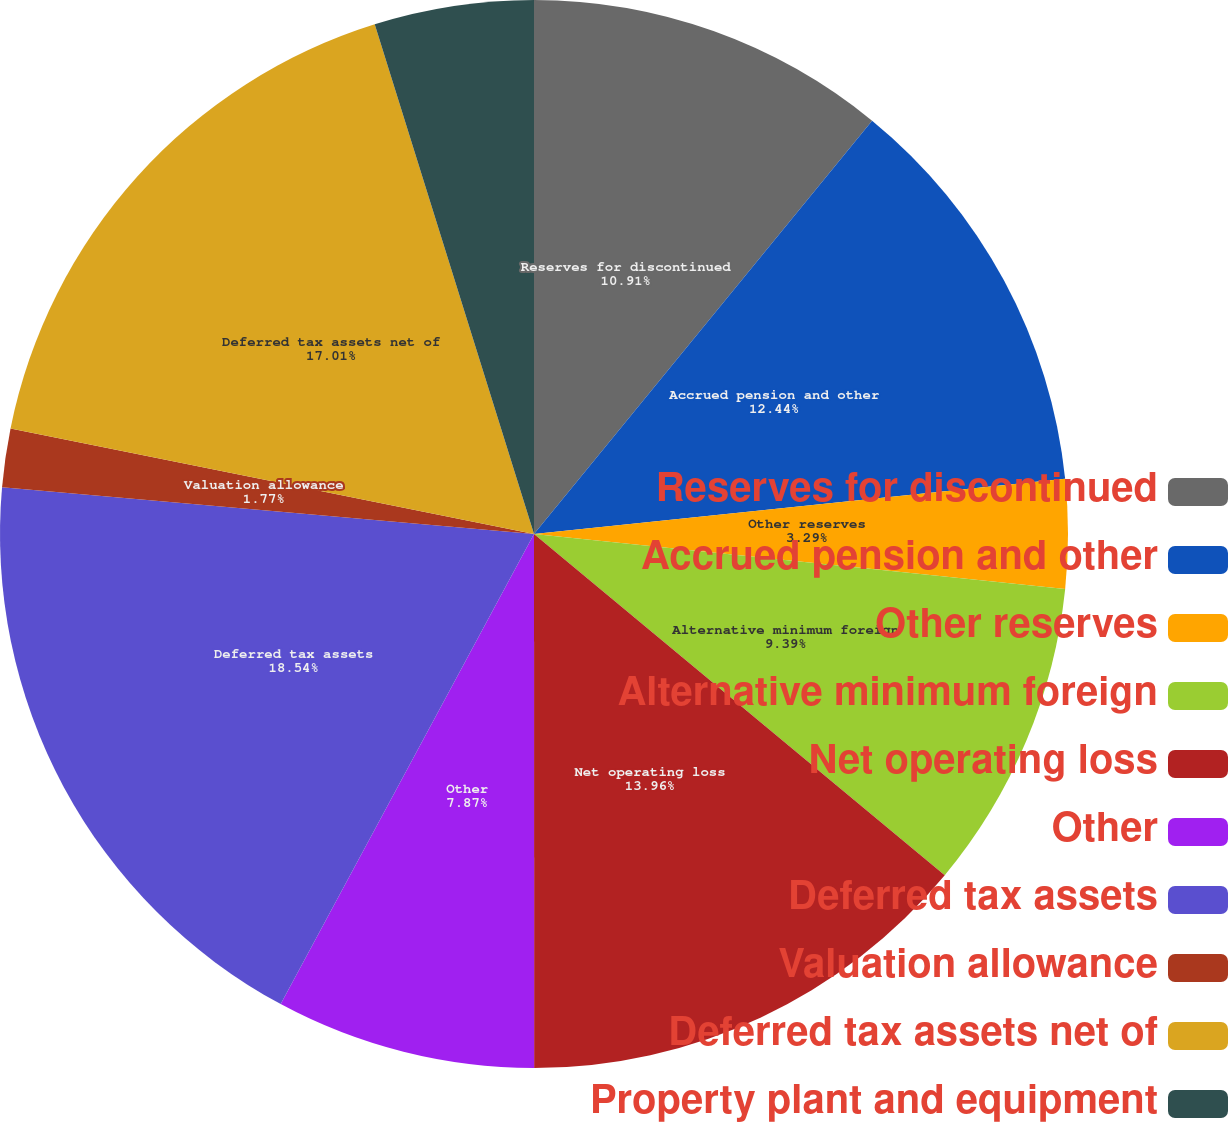<chart> <loc_0><loc_0><loc_500><loc_500><pie_chart><fcel>Reserves for discontinued<fcel>Accrued pension and other<fcel>Other reserves<fcel>Alternative minimum foreign<fcel>Net operating loss<fcel>Other<fcel>Deferred tax assets<fcel>Valuation allowance<fcel>Deferred tax assets net of<fcel>Property plant and equipment<nl><fcel>10.91%<fcel>12.44%<fcel>3.29%<fcel>9.39%<fcel>13.96%<fcel>7.87%<fcel>18.53%<fcel>1.77%<fcel>17.01%<fcel>4.82%<nl></chart> 